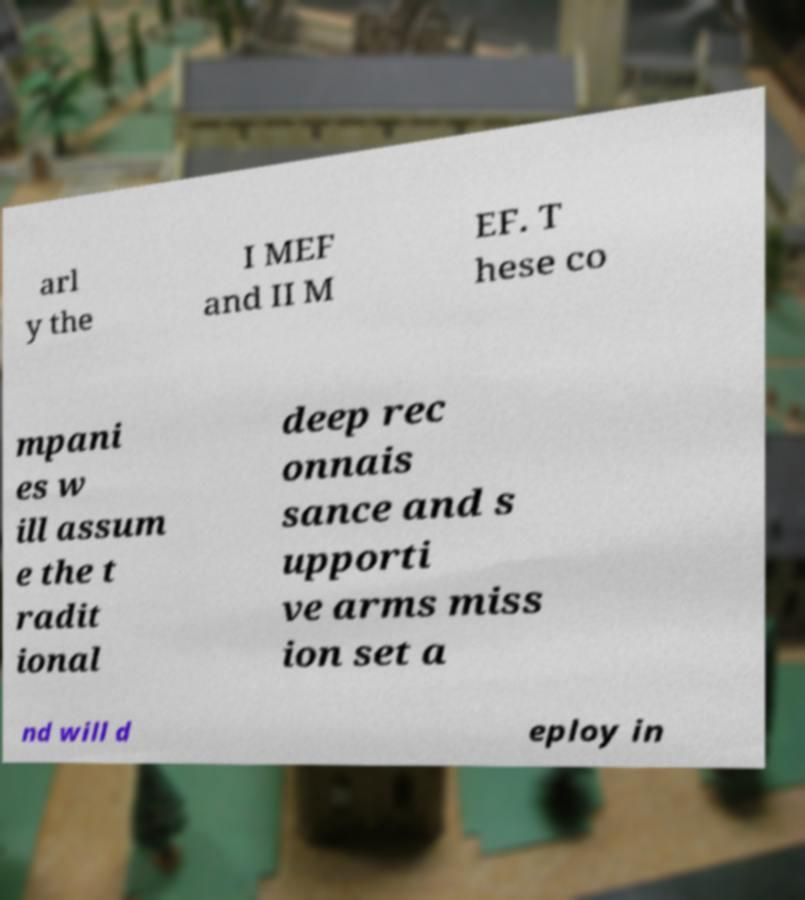Can you accurately transcribe the text from the provided image for me? arl y the I MEF and II M EF. T hese co mpani es w ill assum e the t radit ional deep rec onnais sance and s upporti ve arms miss ion set a nd will d eploy in 